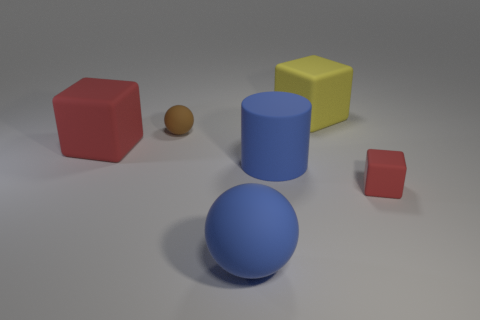Are there any other small matte balls of the same color as the tiny ball? Upon reviewing the image, there are no other small matte balls that match the color of the tiny brown ball in the scene. The other objects, while varied in shape and color, do not replicate the specific characteristics of the tiny ball in question. The closest object is a larger blue matte ball, but it differs in both size and color. 